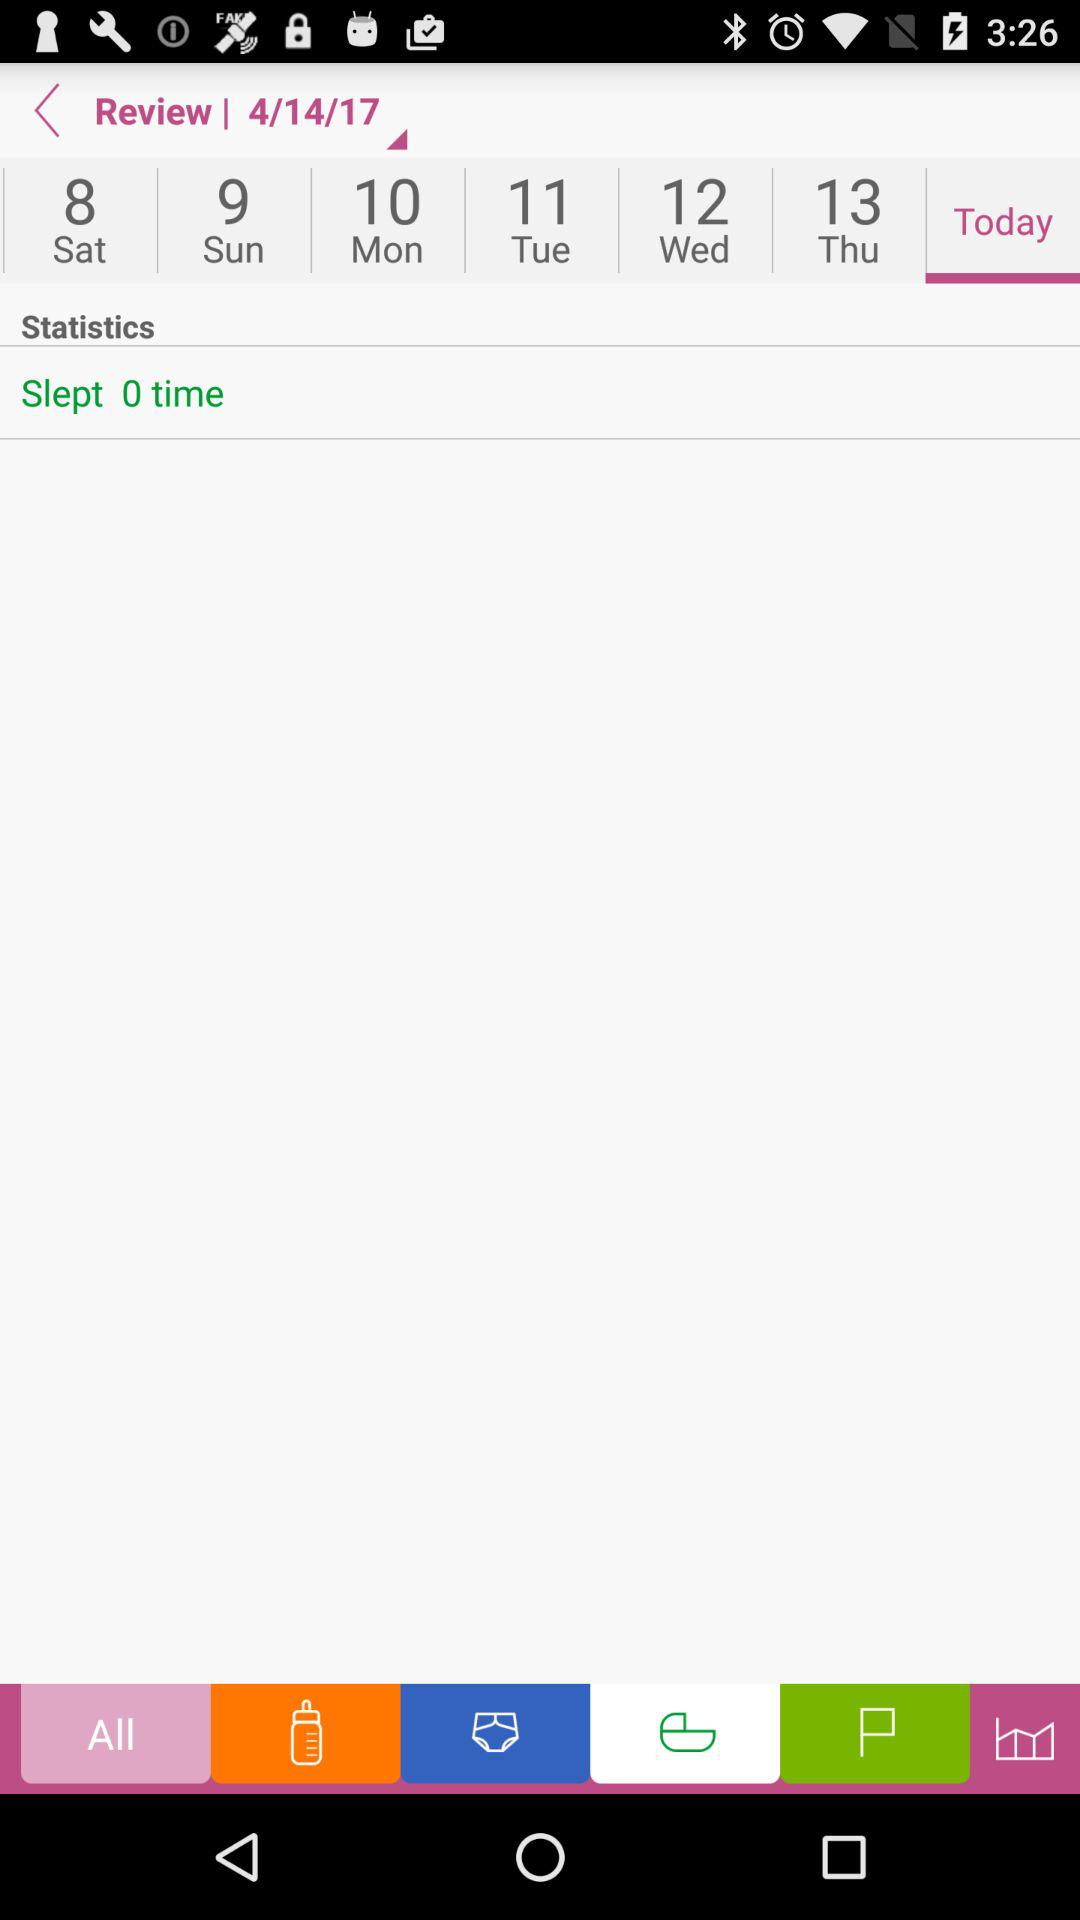Which date is selected? The selected date is April 14, 2017. 